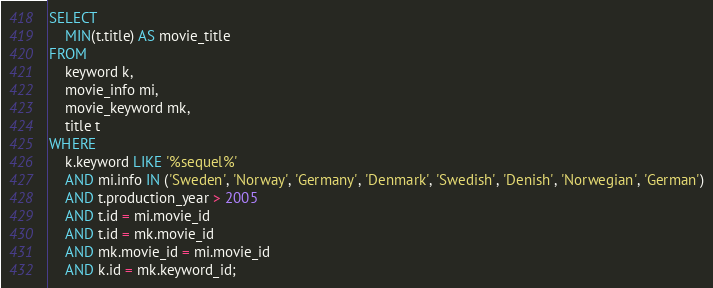Convert code to text. <code><loc_0><loc_0><loc_500><loc_500><_SQL_>SELECT
    MIN(t.title) AS movie_title
FROM
    keyword k,
    movie_info mi,
    movie_keyword mk,
    title t
WHERE
    k.keyword LIKE '%sequel%'
    AND mi.info IN ('Sweden', 'Norway', 'Germany', 'Denmark', 'Swedish', 'Denish', 'Norwegian', 'German')
    AND t.production_year > 2005
    AND t.id = mi.movie_id
    AND t.id = mk.movie_id
    AND mk.movie_id = mi.movie_id
    AND k.id = mk.keyword_id;
</code> 